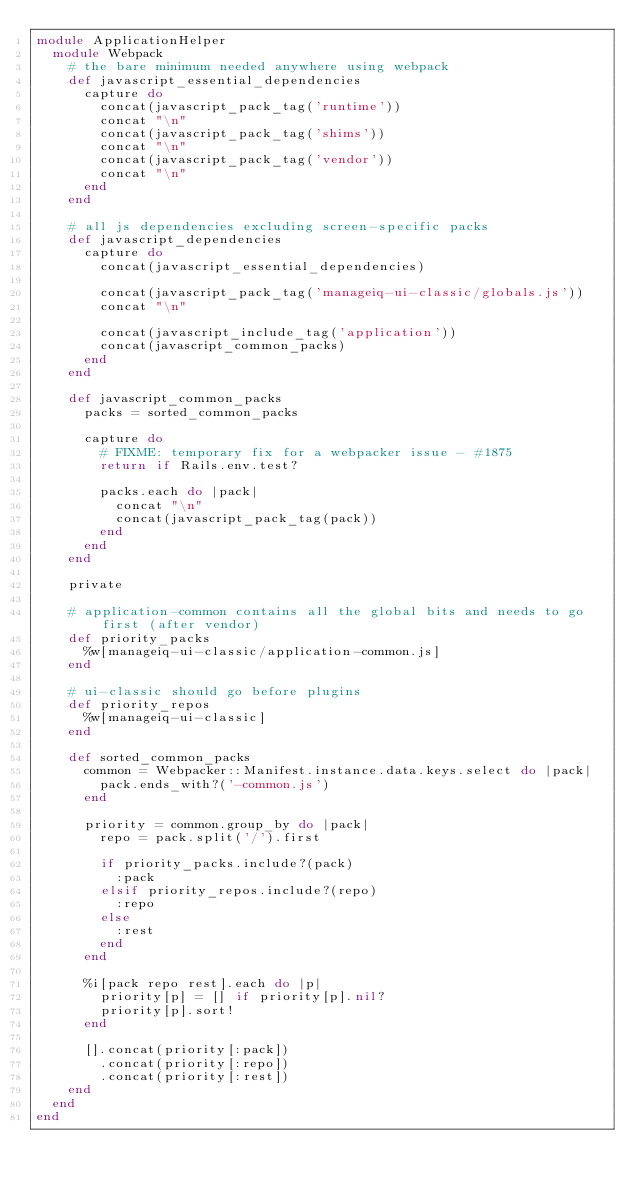Convert code to text. <code><loc_0><loc_0><loc_500><loc_500><_Ruby_>module ApplicationHelper
  module Webpack
    # the bare minimum needed anywhere using webpack
    def javascript_essential_dependencies
      capture do
        concat(javascript_pack_tag('runtime'))
        concat "\n"
        concat(javascript_pack_tag('shims'))
        concat "\n"
        concat(javascript_pack_tag('vendor'))
        concat "\n"
      end
    end

    # all js dependencies excluding screen-specific packs
    def javascript_dependencies
      capture do
        concat(javascript_essential_dependencies)

        concat(javascript_pack_tag('manageiq-ui-classic/globals.js'))
        concat "\n"

        concat(javascript_include_tag('application'))
        concat(javascript_common_packs)
      end
    end

    def javascript_common_packs
      packs = sorted_common_packs

      capture do
        # FIXME: temporary fix for a webpacker issue - #1875
        return if Rails.env.test?

        packs.each do |pack|
          concat "\n"
          concat(javascript_pack_tag(pack))
        end
      end
    end

    private

    # application-common contains all the global bits and needs to go first (after vendor)
    def priority_packs
      %w[manageiq-ui-classic/application-common.js]
    end

    # ui-classic should go before plugins
    def priority_repos
      %w[manageiq-ui-classic]
    end

    def sorted_common_packs
      common = Webpacker::Manifest.instance.data.keys.select do |pack|
        pack.ends_with?('-common.js')
      end

      priority = common.group_by do |pack|
        repo = pack.split('/').first

        if priority_packs.include?(pack)
          :pack
        elsif priority_repos.include?(repo)
          :repo
        else
          :rest
        end
      end

      %i[pack repo rest].each do |p|
        priority[p] = [] if priority[p].nil?
        priority[p].sort!
      end

      [].concat(priority[:pack])
        .concat(priority[:repo])
        .concat(priority[:rest])
    end
  end
end
</code> 